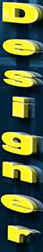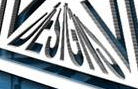What words can you see in these images in sequence, separated by a semicolon? Designer; DESIGNS 